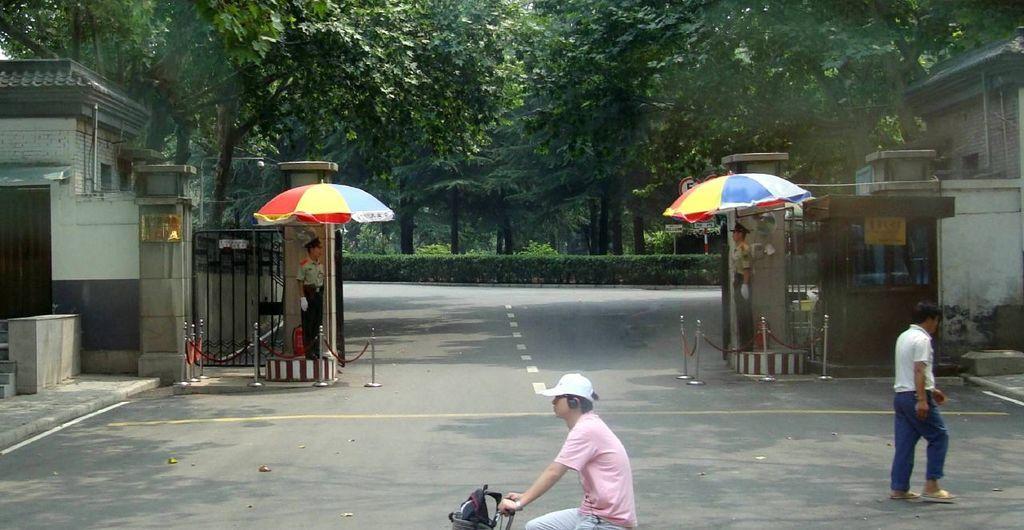In one or two sentences, can you explain what this image depicts? In this image we can see buildings, barrier poles, persons standing under the parasols, person standing on the road, person riding the bicycle, bushes, plants and trees. 